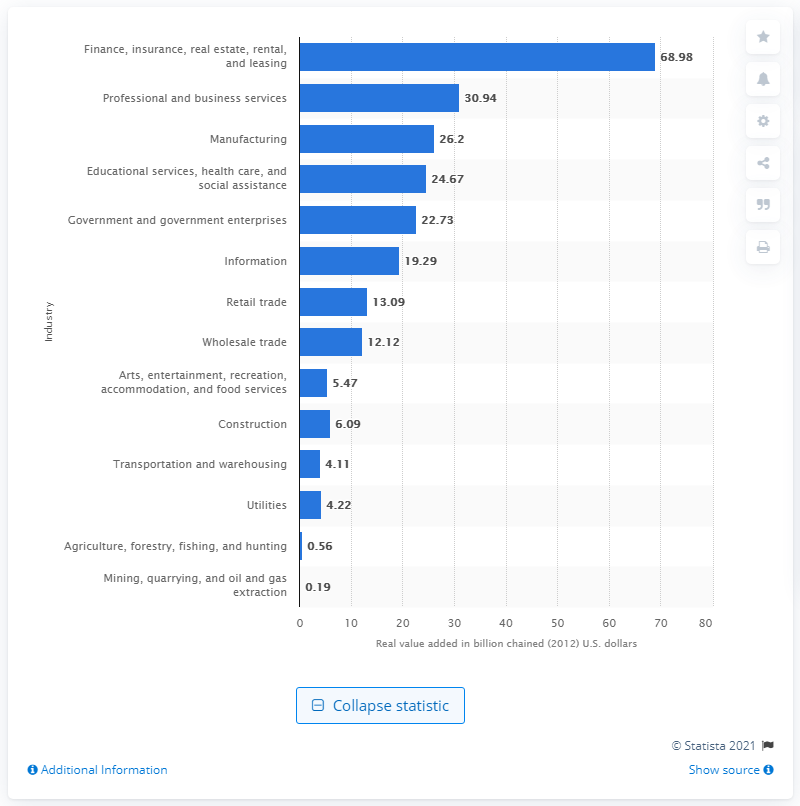What's the second-largest industry contributor to Connecticut's GDP? The second-largest contributor to Connecticut's GDP is the professional and business services industry, with a contribution of $30.94 billion. 